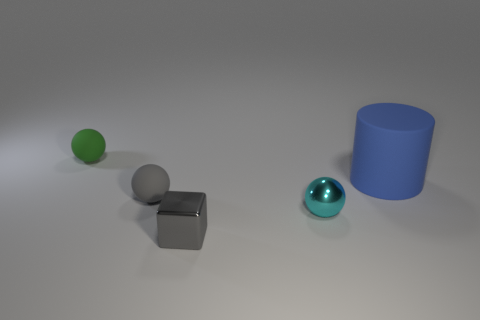Does the gray sphere on the left side of the cube have the same size as the cyan metal object?
Offer a very short reply. Yes. What color is the other object that is made of the same material as the cyan object?
Give a very brief answer. Gray. Are there any other things that have the same size as the blue matte cylinder?
Offer a terse response. No. How many large blue rubber cylinders are behind the cyan metallic object?
Provide a short and direct response. 1. Is the color of the rubber object behind the matte cylinder the same as the thing on the right side of the cyan metallic ball?
Offer a very short reply. No. What is the color of the metal object that is the same shape as the green matte object?
Provide a succinct answer. Cyan. Is there any other thing that is the same shape as the small gray matte object?
Your answer should be very brief. Yes. Is the shape of the small green rubber object on the left side of the gray metal object the same as the tiny rubber thing that is in front of the green rubber ball?
Keep it short and to the point. Yes. There is a green matte object; does it have the same size as the rubber thing that is on the right side of the gray matte thing?
Offer a very short reply. No. Are there more tiny green balls than yellow objects?
Your response must be concise. Yes. 